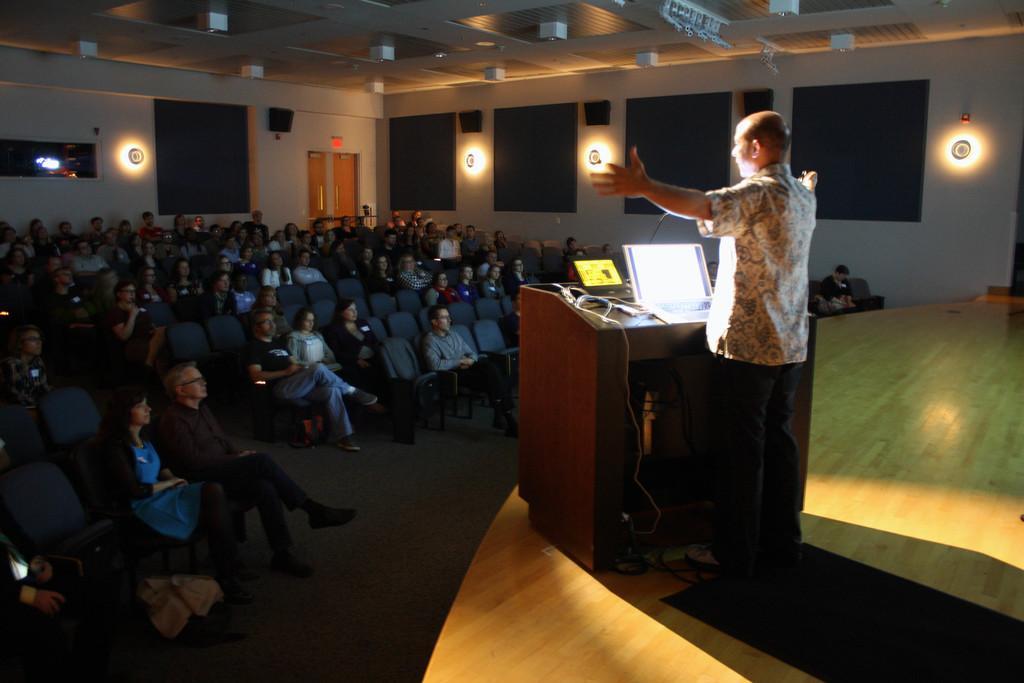Could you give a brief overview of what you see in this image? In this image we can see a person standing on the stage near the table containing a laptop, wires and a mike. On the left side we can see some people sitting on the chairs. We can also see some empty chairs. On the backside we can see some doors, roof and a ceiling light. 